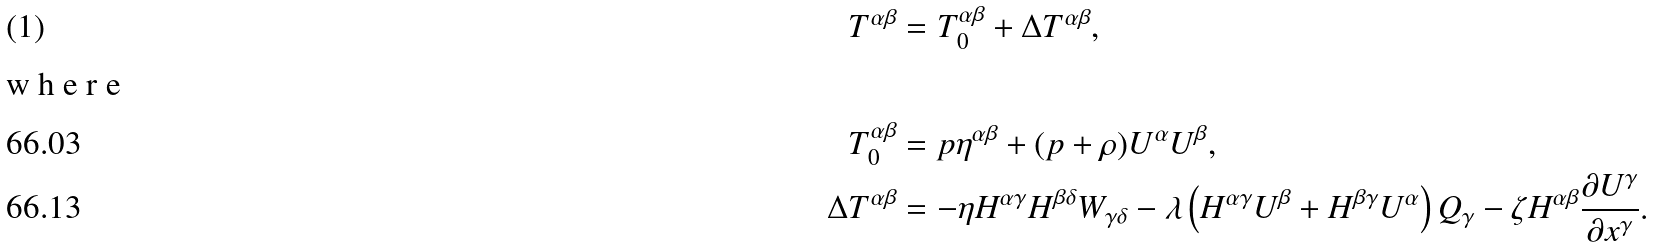<formula> <loc_0><loc_0><loc_500><loc_500>T ^ { \alpha \beta } & = T _ { 0 } ^ { \alpha \beta } + \Delta T ^ { \alpha \beta } , \intertext { w h e r e } T _ { 0 } ^ { \alpha \beta } & = p \eta ^ { \alpha \beta } + ( p + \rho ) U ^ { \alpha } U ^ { \beta } , \\ \Delta T ^ { \alpha \beta } & = - \eta H ^ { \alpha \gamma } H ^ { \beta \delta } W _ { \gamma \delta } - \lambda \left ( H ^ { \alpha \gamma } U ^ { \beta } + H ^ { \beta \gamma } U ^ { \alpha } \right ) Q _ { \gamma } - \zeta H ^ { \alpha \beta } \frac { \partial U ^ { \gamma } } { \partial x ^ { \gamma } } .</formula> 